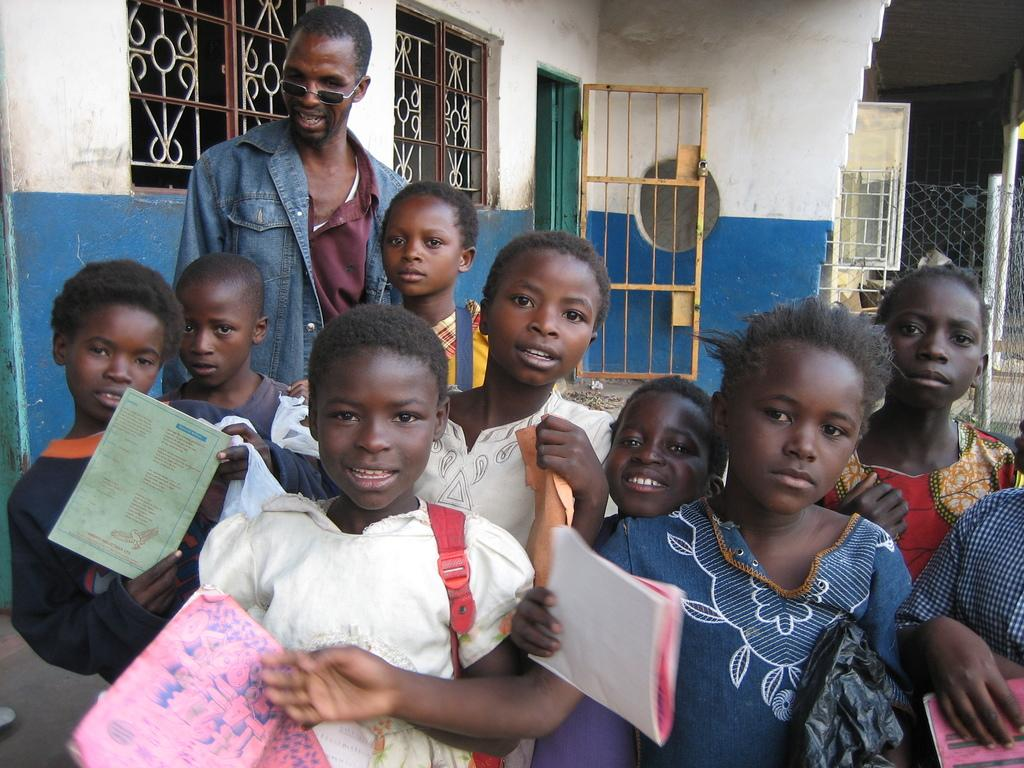Who is present in the image? There are children in the image. Can you describe the background of the image? There is a man in the background of the image. What architectural features can be seen in the image? Windows and doors are present in the image. What is located on the right side of the image? There is fencing on the right side of the image. What type of calculator is being used by the children in the image? There is no calculator present in the image; it features children and a man in the background, along with architectural features and fencing. 